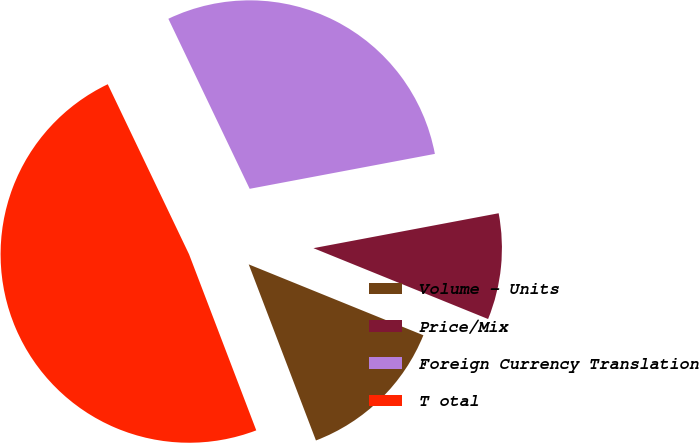<chart> <loc_0><loc_0><loc_500><loc_500><pie_chart><fcel>Volume - Units<fcel>Price/Mix<fcel>Foreign Currency Translation<fcel>T otal<nl><fcel>13.06%<fcel>9.1%<fcel>29.13%<fcel>48.7%<nl></chart> 